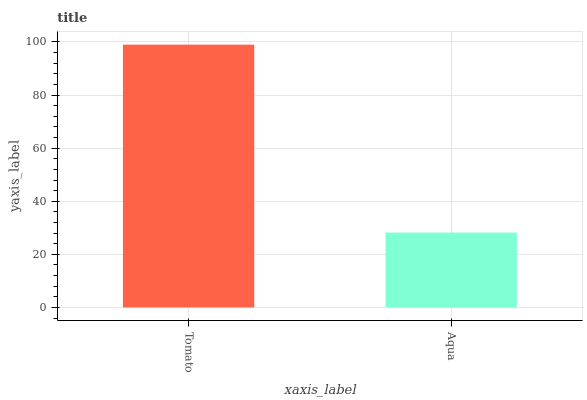Is Aqua the maximum?
Answer yes or no. No. Is Tomato greater than Aqua?
Answer yes or no. Yes. Is Aqua less than Tomato?
Answer yes or no. Yes. Is Aqua greater than Tomato?
Answer yes or no. No. Is Tomato less than Aqua?
Answer yes or no. No. Is Tomato the high median?
Answer yes or no. Yes. Is Aqua the low median?
Answer yes or no. Yes. Is Aqua the high median?
Answer yes or no. No. Is Tomato the low median?
Answer yes or no. No. 